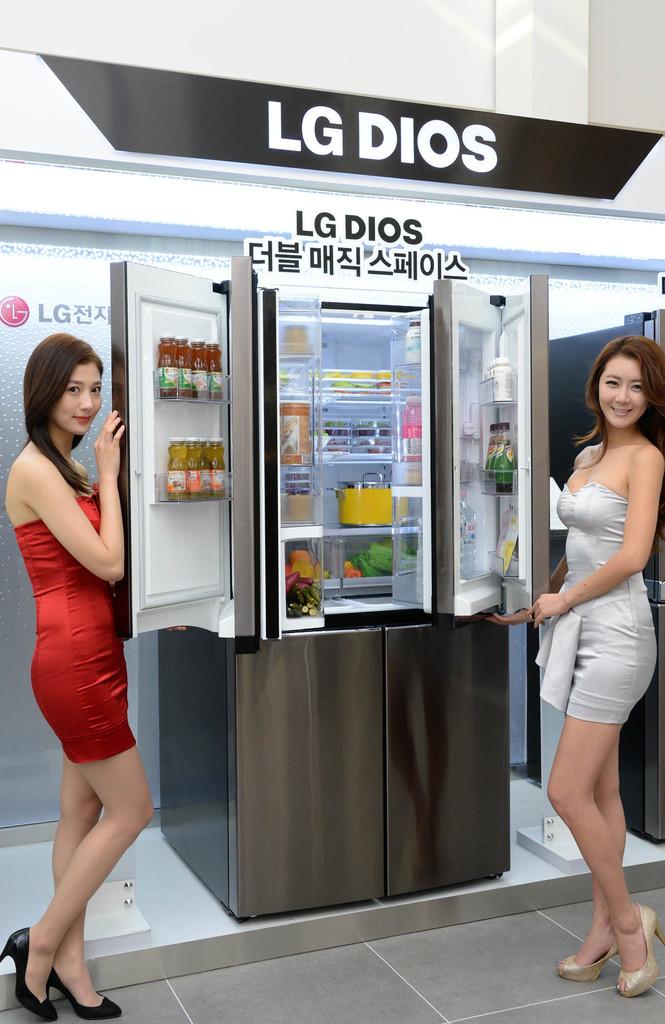Which company is this appliance made by?
Make the answer very short. Lg dios. What model is this refrigerator?
Your response must be concise. Lg dios. 